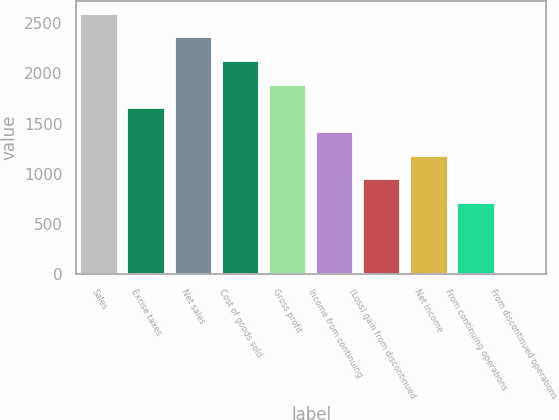Convert chart. <chart><loc_0><loc_0><loc_500><loc_500><bar_chart><fcel>Sales<fcel>Excise taxes<fcel>Net sales<fcel>Cost of goods sold<fcel>Gross profit<fcel>Income from continuing<fcel>(Loss) gain from discontinued<fcel>Net income<fcel>From continuing operations<fcel>From discontinued operations<nl><fcel>2595.3<fcel>1651.58<fcel>2359.37<fcel>2123.44<fcel>1887.51<fcel>1415.65<fcel>943.79<fcel>1179.72<fcel>707.86<fcel>0.07<nl></chart> 